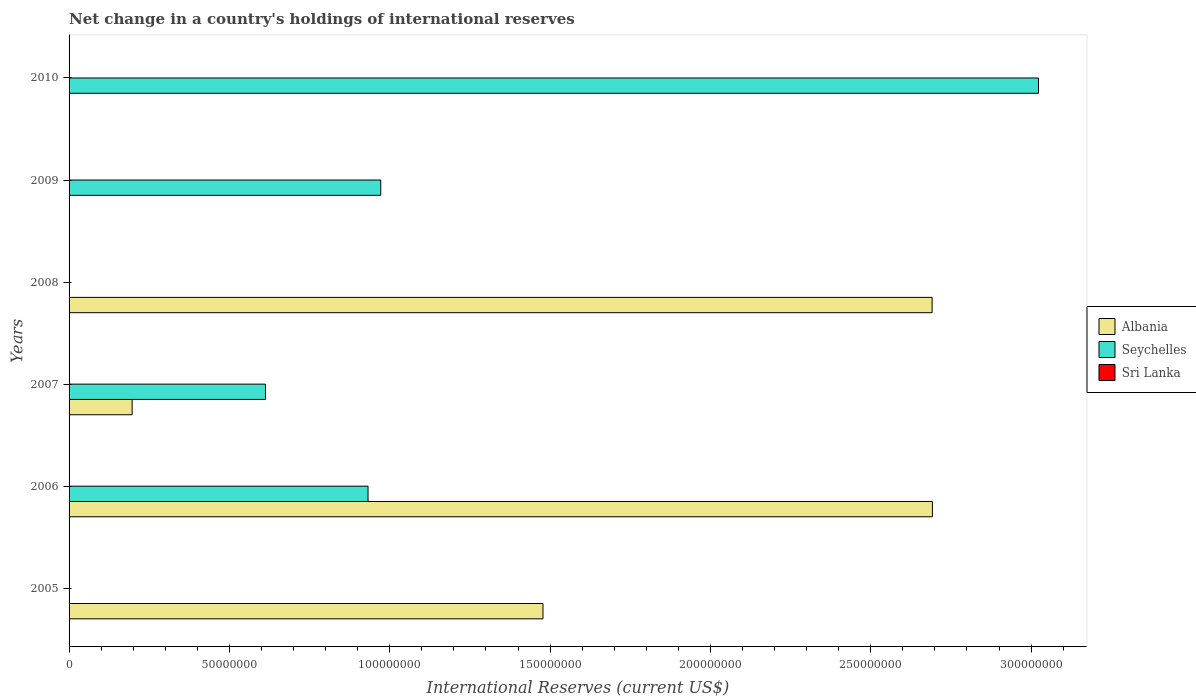How many bars are there on the 6th tick from the top?
Ensure brevity in your answer.  1. What is the label of the 5th group of bars from the top?
Your answer should be compact. 2006. What is the international reserves in Sri Lanka in 2010?
Your answer should be compact. 0. Across all years, what is the maximum international reserves in Seychelles?
Offer a terse response. 3.02e+08. Across all years, what is the minimum international reserves in Albania?
Your answer should be compact. 0. In which year was the international reserves in Albania maximum?
Your response must be concise. 2006. What is the total international reserves in Seychelles in the graph?
Ensure brevity in your answer.  5.54e+08. What is the difference between the international reserves in Albania in 2006 and that in 2008?
Provide a succinct answer. 8.90e+04. What is the difference between the international reserves in Sri Lanka in 2008 and the international reserves in Seychelles in 2007?
Provide a short and direct response. -6.12e+07. What is the average international reserves in Albania per year?
Ensure brevity in your answer.  1.18e+08. In the year 2006, what is the difference between the international reserves in Seychelles and international reserves in Albania?
Your response must be concise. -1.76e+08. In how many years, is the international reserves in Sri Lanka greater than 140000000 US$?
Your response must be concise. 0. What is the ratio of the international reserves in Albania in 2005 to that in 2007?
Make the answer very short. 7.51. Is the international reserves in Seychelles in 2007 less than that in 2010?
Your answer should be very brief. Yes. Is the difference between the international reserves in Seychelles in 2006 and 2007 greater than the difference between the international reserves in Albania in 2006 and 2007?
Offer a terse response. No. What is the difference between the highest and the second highest international reserves in Seychelles?
Your answer should be compact. 2.05e+08. What is the difference between the highest and the lowest international reserves in Seychelles?
Offer a terse response. 3.02e+08. In how many years, is the international reserves in Sri Lanka greater than the average international reserves in Sri Lanka taken over all years?
Your answer should be very brief. 0. Is it the case that in every year, the sum of the international reserves in Sri Lanka and international reserves in Seychelles is greater than the international reserves in Albania?
Give a very brief answer. No. Are all the bars in the graph horizontal?
Provide a succinct answer. Yes. What is the difference between two consecutive major ticks on the X-axis?
Provide a short and direct response. 5.00e+07. Are the values on the major ticks of X-axis written in scientific E-notation?
Ensure brevity in your answer.  No. How are the legend labels stacked?
Offer a very short reply. Vertical. What is the title of the graph?
Your response must be concise. Net change in a country's holdings of international reserves. What is the label or title of the X-axis?
Give a very brief answer. International Reserves (current US$). What is the label or title of the Y-axis?
Make the answer very short. Years. What is the International Reserves (current US$) of Albania in 2005?
Make the answer very short. 1.48e+08. What is the International Reserves (current US$) in Sri Lanka in 2005?
Offer a terse response. 0. What is the International Reserves (current US$) of Albania in 2006?
Give a very brief answer. 2.69e+08. What is the International Reserves (current US$) in Seychelles in 2006?
Offer a terse response. 9.32e+07. What is the International Reserves (current US$) in Albania in 2007?
Make the answer very short. 1.97e+07. What is the International Reserves (current US$) of Seychelles in 2007?
Give a very brief answer. 6.12e+07. What is the International Reserves (current US$) in Sri Lanka in 2007?
Give a very brief answer. 0. What is the International Reserves (current US$) of Albania in 2008?
Offer a terse response. 2.69e+08. What is the International Reserves (current US$) in Albania in 2009?
Make the answer very short. 0. What is the International Reserves (current US$) in Seychelles in 2009?
Your answer should be very brief. 9.72e+07. What is the International Reserves (current US$) in Seychelles in 2010?
Make the answer very short. 3.02e+08. Across all years, what is the maximum International Reserves (current US$) in Albania?
Provide a succinct answer. 2.69e+08. Across all years, what is the maximum International Reserves (current US$) in Seychelles?
Provide a succinct answer. 3.02e+08. Across all years, what is the minimum International Reserves (current US$) in Seychelles?
Make the answer very short. 0. What is the total International Reserves (current US$) of Albania in the graph?
Your response must be concise. 7.06e+08. What is the total International Reserves (current US$) in Seychelles in the graph?
Keep it short and to the point. 5.54e+08. What is the difference between the International Reserves (current US$) in Albania in 2005 and that in 2006?
Ensure brevity in your answer.  -1.21e+08. What is the difference between the International Reserves (current US$) of Albania in 2005 and that in 2007?
Your answer should be very brief. 1.28e+08. What is the difference between the International Reserves (current US$) of Albania in 2005 and that in 2008?
Offer a very short reply. -1.21e+08. What is the difference between the International Reserves (current US$) in Albania in 2006 and that in 2007?
Offer a very short reply. 2.50e+08. What is the difference between the International Reserves (current US$) in Seychelles in 2006 and that in 2007?
Offer a terse response. 3.20e+07. What is the difference between the International Reserves (current US$) of Albania in 2006 and that in 2008?
Your response must be concise. 8.90e+04. What is the difference between the International Reserves (current US$) of Seychelles in 2006 and that in 2009?
Offer a very short reply. -3.97e+06. What is the difference between the International Reserves (current US$) in Seychelles in 2006 and that in 2010?
Keep it short and to the point. -2.09e+08. What is the difference between the International Reserves (current US$) in Albania in 2007 and that in 2008?
Provide a short and direct response. -2.49e+08. What is the difference between the International Reserves (current US$) of Seychelles in 2007 and that in 2009?
Offer a terse response. -3.60e+07. What is the difference between the International Reserves (current US$) in Seychelles in 2007 and that in 2010?
Offer a terse response. -2.41e+08. What is the difference between the International Reserves (current US$) in Seychelles in 2009 and that in 2010?
Provide a short and direct response. -2.05e+08. What is the difference between the International Reserves (current US$) of Albania in 2005 and the International Reserves (current US$) of Seychelles in 2006?
Give a very brief answer. 5.45e+07. What is the difference between the International Reserves (current US$) of Albania in 2005 and the International Reserves (current US$) of Seychelles in 2007?
Your answer should be very brief. 8.65e+07. What is the difference between the International Reserves (current US$) of Albania in 2005 and the International Reserves (current US$) of Seychelles in 2009?
Provide a short and direct response. 5.06e+07. What is the difference between the International Reserves (current US$) of Albania in 2005 and the International Reserves (current US$) of Seychelles in 2010?
Your answer should be compact. -1.55e+08. What is the difference between the International Reserves (current US$) of Albania in 2006 and the International Reserves (current US$) of Seychelles in 2007?
Make the answer very short. 2.08e+08. What is the difference between the International Reserves (current US$) of Albania in 2006 and the International Reserves (current US$) of Seychelles in 2009?
Offer a very short reply. 1.72e+08. What is the difference between the International Reserves (current US$) in Albania in 2006 and the International Reserves (current US$) in Seychelles in 2010?
Offer a very short reply. -3.31e+07. What is the difference between the International Reserves (current US$) in Albania in 2007 and the International Reserves (current US$) in Seychelles in 2009?
Your answer should be very brief. -7.75e+07. What is the difference between the International Reserves (current US$) in Albania in 2007 and the International Reserves (current US$) in Seychelles in 2010?
Offer a terse response. -2.83e+08. What is the difference between the International Reserves (current US$) in Albania in 2008 and the International Reserves (current US$) in Seychelles in 2009?
Make the answer very short. 1.72e+08. What is the difference between the International Reserves (current US$) of Albania in 2008 and the International Reserves (current US$) of Seychelles in 2010?
Give a very brief answer. -3.32e+07. What is the average International Reserves (current US$) of Albania per year?
Ensure brevity in your answer.  1.18e+08. What is the average International Reserves (current US$) of Seychelles per year?
Make the answer very short. 9.23e+07. In the year 2006, what is the difference between the International Reserves (current US$) of Albania and International Reserves (current US$) of Seychelles?
Offer a very short reply. 1.76e+08. In the year 2007, what is the difference between the International Reserves (current US$) of Albania and International Reserves (current US$) of Seychelles?
Offer a terse response. -4.16e+07. What is the ratio of the International Reserves (current US$) of Albania in 2005 to that in 2006?
Provide a short and direct response. 0.55. What is the ratio of the International Reserves (current US$) of Albania in 2005 to that in 2007?
Provide a short and direct response. 7.51. What is the ratio of the International Reserves (current US$) of Albania in 2005 to that in 2008?
Provide a short and direct response. 0.55. What is the ratio of the International Reserves (current US$) of Albania in 2006 to that in 2007?
Your answer should be compact. 13.69. What is the ratio of the International Reserves (current US$) of Seychelles in 2006 to that in 2007?
Offer a terse response. 1.52. What is the ratio of the International Reserves (current US$) in Albania in 2006 to that in 2008?
Give a very brief answer. 1. What is the ratio of the International Reserves (current US$) in Seychelles in 2006 to that in 2009?
Provide a succinct answer. 0.96. What is the ratio of the International Reserves (current US$) in Seychelles in 2006 to that in 2010?
Give a very brief answer. 0.31. What is the ratio of the International Reserves (current US$) in Albania in 2007 to that in 2008?
Give a very brief answer. 0.07. What is the ratio of the International Reserves (current US$) of Seychelles in 2007 to that in 2009?
Offer a terse response. 0.63. What is the ratio of the International Reserves (current US$) in Seychelles in 2007 to that in 2010?
Your answer should be very brief. 0.2. What is the ratio of the International Reserves (current US$) in Seychelles in 2009 to that in 2010?
Your answer should be very brief. 0.32. What is the difference between the highest and the second highest International Reserves (current US$) of Albania?
Your answer should be very brief. 8.90e+04. What is the difference between the highest and the second highest International Reserves (current US$) of Seychelles?
Offer a terse response. 2.05e+08. What is the difference between the highest and the lowest International Reserves (current US$) in Albania?
Offer a terse response. 2.69e+08. What is the difference between the highest and the lowest International Reserves (current US$) of Seychelles?
Make the answer very short. 3.02e+08. 